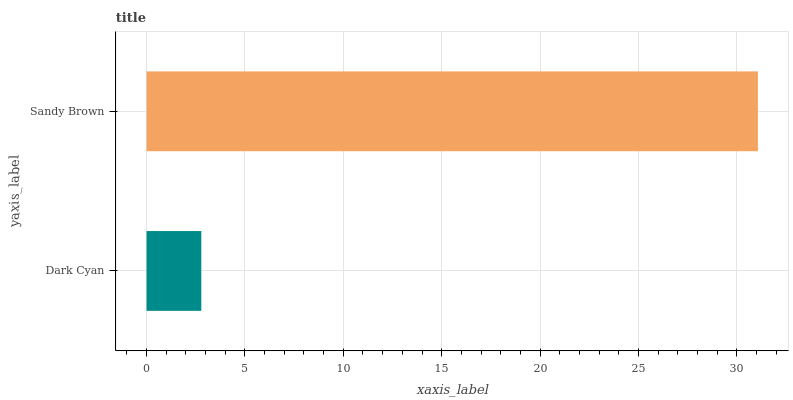Is Dark Cyan the minimum?
Answer yes or no. Yes. Is Sandy Brown the maximum?
Answer yes or no. Yes. Is Sandy Brown the minimum?
Answer yes or no. No. Is Sandy Brown greater than Dark Cyan?
Answer yes or no. Yes. Is Dark Cyan less than Sandy Brown?
Answer yes or no. Yes. Is Dark Cyan greater than Sandy Brown?
Answer yes or no. No. Is Sandy Brown less than Dark Cyan?
Answer yes or no. No. Is Sandy Brown the high median?
Answer yes or no. Yes. Is Dark Cyan the low median?
Answer yes or no. Yes. Is Dark Cyan the high median?
Answer yes or no. No. Is Sandy Brown the low median?
Answer yes or no. No. 